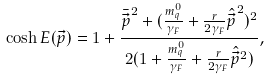Convert formula to latex. <formula><loc_0><loc_0><loc_500><loc_500>\cosh E ( \vec { p } ) = 1 + \frac { { \bar { \vec { p } } } ^ { 2 } + ( \frac { m _ { q } ^ { 0 } } { \gamma _ { F } } + \frac { r } { 2 \gamma _ { F } } { \hat { \vec { p } } } ^ { 2 } ) ^ { 2 } } { 2 ( 1 + \frac { m _ { q } ^ { 0 } } { \gamma _ { F } } + \frac { r } { 2 \gamma _ { F } } \hat { \vec { p } } ^ { 2 } ) } ,</formula> 